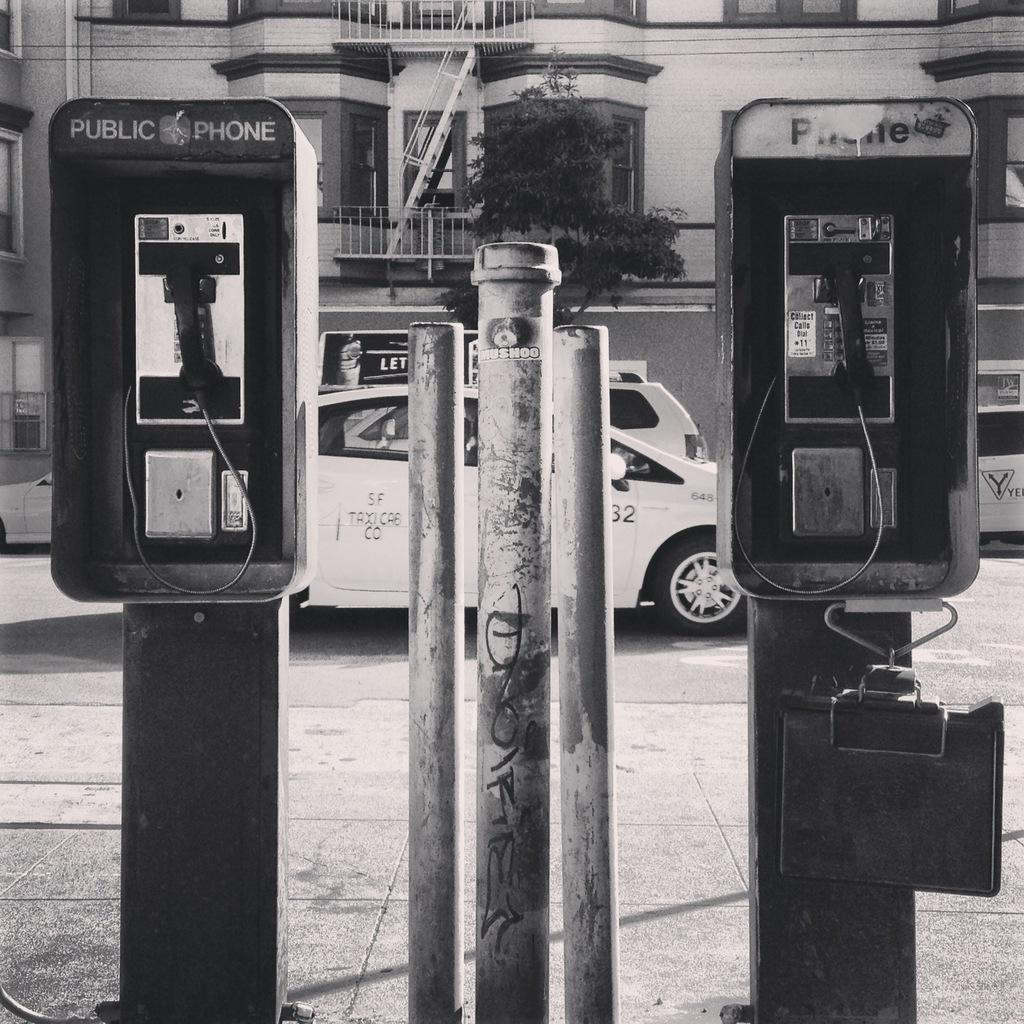Provide a one-sentence caption for the provided image. The pay phones in the black and white photo have "public phone" on them. 